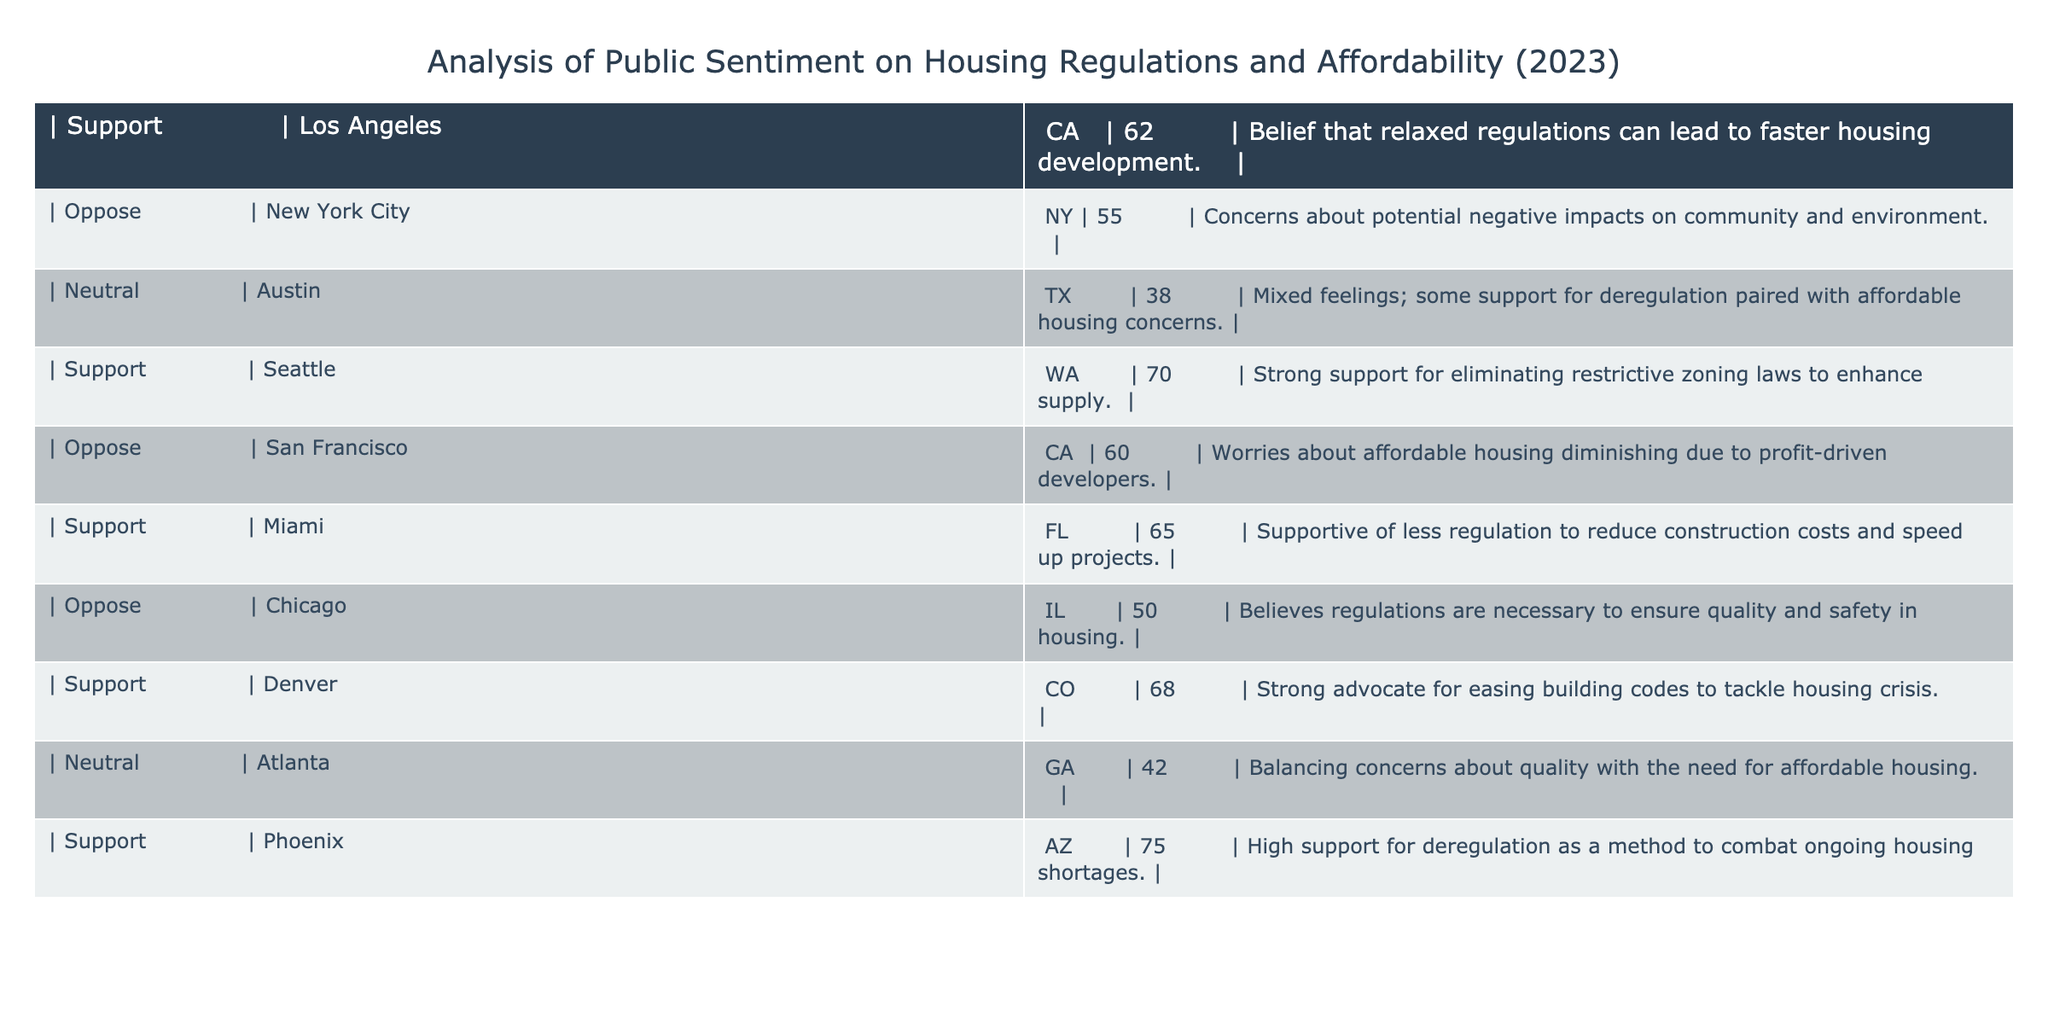What is the level of support for relaxed housing regulations in Phoenix, AZ? The table lists Phoenix, AZ in the "Support" category with a value of 75. To find the support level specifically for Phoenix, we reference that entry directly.
Answer: 75 Which city shows the lowest support for reduced housing regulations? The table contains various support levels by city. By comparing the values, we see Austin, TX has the lowest support rating at 38.
Answer: 38 How many cities in the table have a support level of over 65? We count the support levels: Los Angeles (62), Seattle (70), Miami (65), Denver (68), and Phoenix (75). Only Seattle, Miami, Denver, and Phoenix exceed 65, totaling four cities.
Answer: 4 What is the average support level for cities that oppose relaxed regulations? In the table, the opposing cities are New York City (55), San Francisco (60), and Chicago (50). We sum these values (55 + 60 + 50 = 165) and divide by the number of cities (3), resulting in an average of 55.
Answer: 55 Is there a city where neutral opinions are higher than the opposing opinions? Neutral opinions are shown for Austin (38) and Atlanta (42); opposing opinions are for New York City (55), San Francisco (60), and Chicago (50). Both neutral values (38 and 42) are lower than all opposing values, confirming there is no such city.
Answer: No Which city has the highest level of opposition and what is the concern expressed? The highest opposition is in San Francisco, CA with a value of 60. The concern expressed is about affordable housing diminishing due to profit-driven developers.
Answer: San Francisco, 60 What percentage of cities in the table are neutral regarding housing regulations? There are 10 cities in total, with 2 showing neutral sentiments (Austin and Atlanta). We calculate the percentage as (2/10) * 100 = 20%.
Answer: 20% Does the overall sentiment in Denver lean more towards support or opposition? Denver shows a support level of 68, while its opposing sentiment is represented by Chicago at 50. Since 68 is greater than 50, we conclude the sentiment in Denver leans more towards support.
Answer: Yes Which two cities have the most significant difference in support levels, and what is that difference? Evaluating all support levels, we find Phoenix (75) and Austin (38) have the most significant difference. The calculation is 75 - 38 = 37.
Answer: 37 